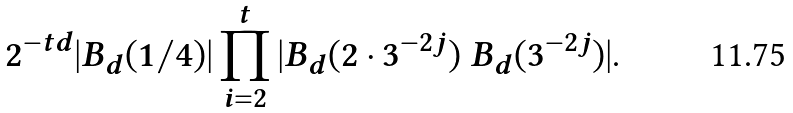Convert formula to latex. <formula><loc_0><loc_0><loc_500><loc_500>2 ^ { - t d } | B _ { d } ( 1 / 4 ) | \prod _ { i = 2 } ^ { t } | B _ { d } ( 2 \cdot 3 ^ { - 2 j } ) \ B _ { d } ( 3 ^ { - 2 j } ) | .</formula> 